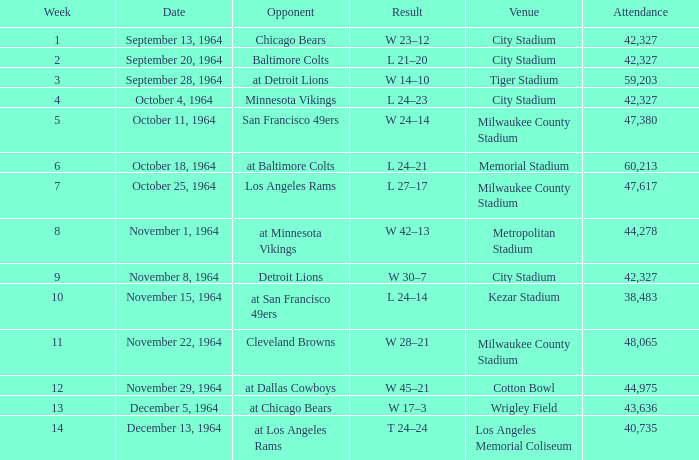What venue held that game with a result of l 24–14? Kezar Stadium. 